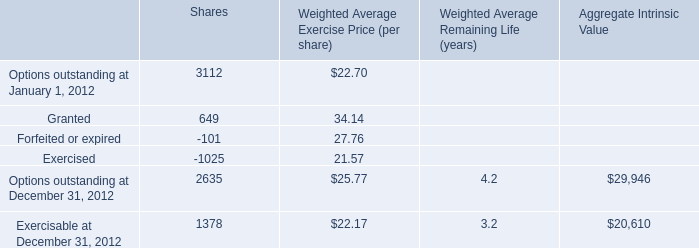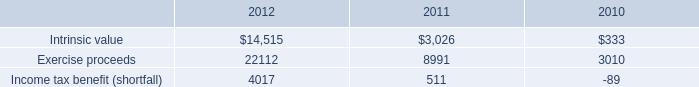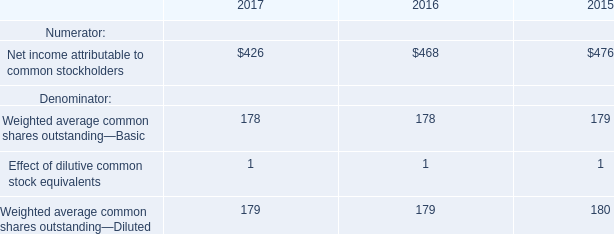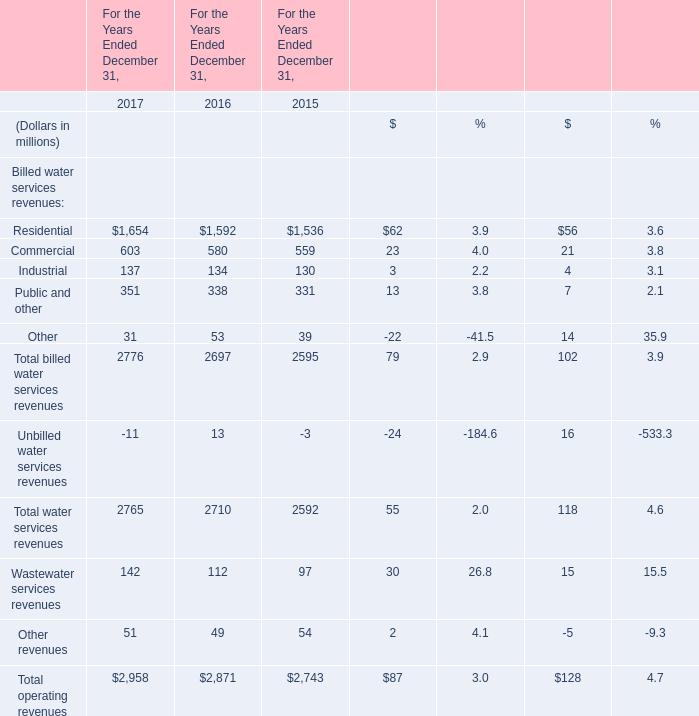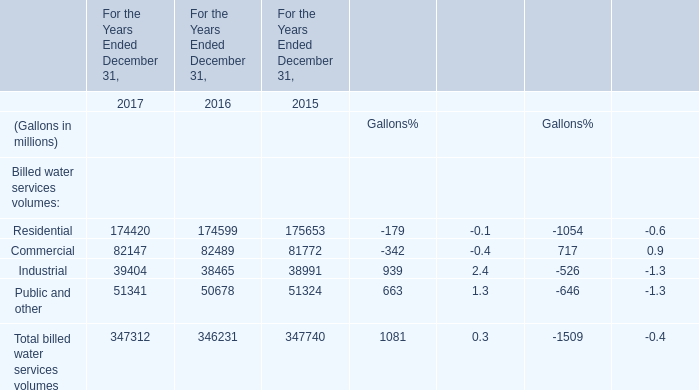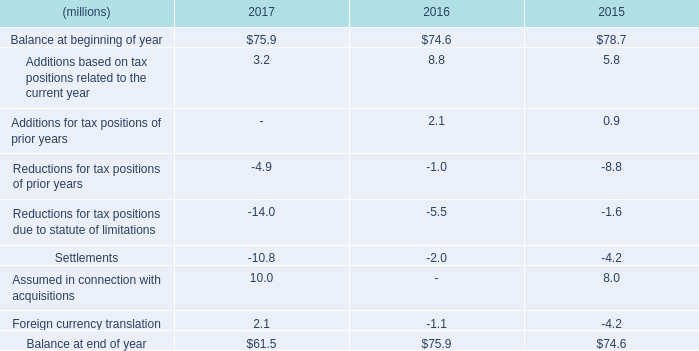What's the sum of the Residential in the years where Commercial is positive? (in million) 
Computations: ((174420 + 174599) + 175653)
Answer: 524672.0. 